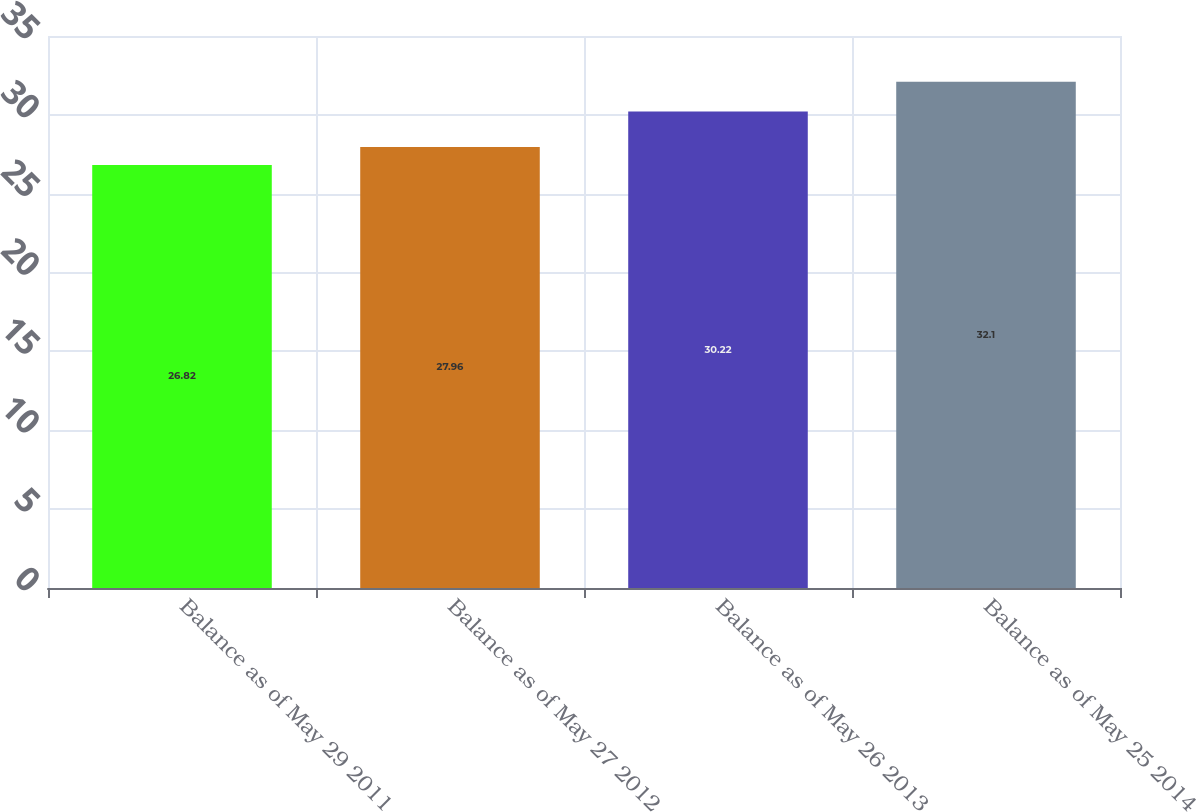Convert chart to OTSL. <chart><loc_0><loc_0><loc_500><loc_500><bar_chart><fcel>Balance as of May 29 2011<fcel>Balance as of May 27 2012<fcel>Balance as of May 26 2013<fcel>Balance as of May 25 2014<nl><fcel>26.82<fcel>27.96<fcel>30.22<fcel>32.1<nl></chart> 